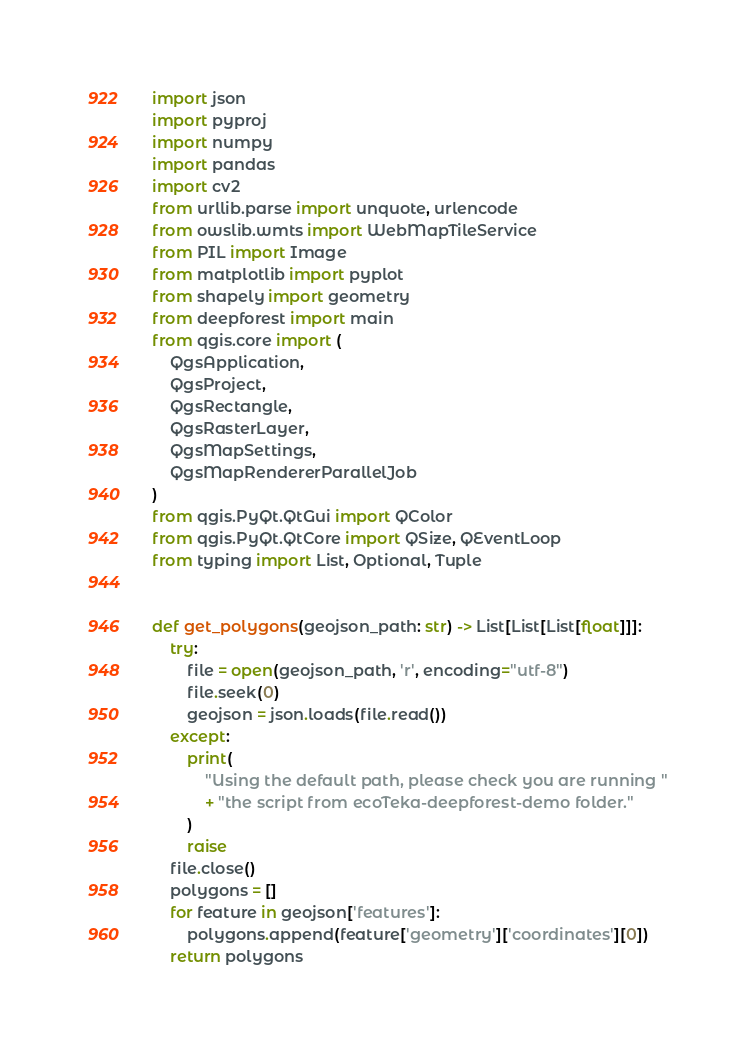Convert code to text. <code><loc_0><loc_0><loc_500><loc_500><_Python_>import json
import pyproj
import numpy
import pandas
import cv2
from urllib.parse import unquote, urlencode
from owslib.wmts import WebMapTileService
from PIL import Image
from matplotlib import pyplot
from shapely import geometry
from deepforest import main
from qgis.core import (
    QgsApplication,
    QgsProject,
    QgsRectangle,
    QgsRasterLayer,
    QgsMapSettings,
    QgsMapRendererParallelJob
)
from qgis.PyQt.QtGui import QColor
from qgis.PyQt.QtCore import QSize, QEventLoop
from typing import List, Optional, Tuple


def get_polygons(geojson_path: str) -> List[List[List[float]]]:
    try:
        file = open(geojson_path, 'r', encoding="utf-8")
        file.seek(0)
        geojson = json.loads(file.read())
    except:
        print(
            "Using the default path, please check you are running "
            + "the script from ecoTeka-deepforest-demo folder."
        )
        raise
    file.close()
    polygons = []
    for feature in geojson['features']:
        polygons.append(feature['geometry']['coordinates'][0])
    return polygons

</code> 